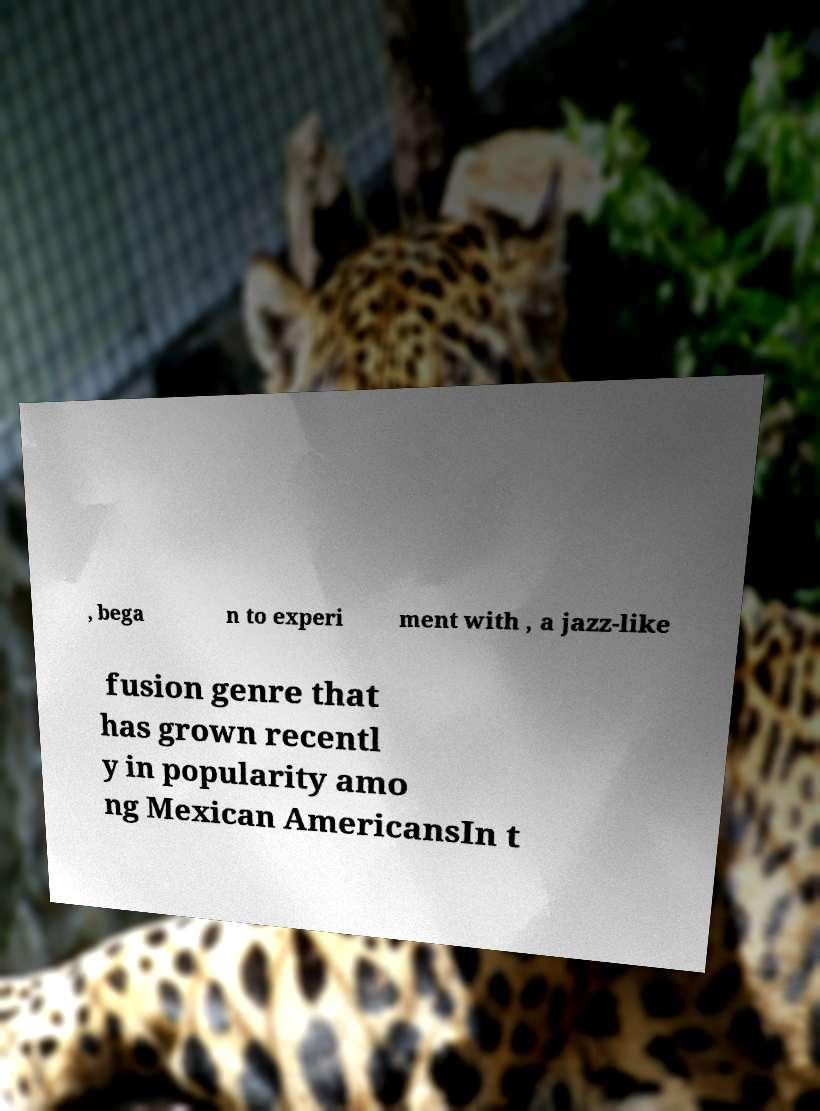Could you extract and type out the text from this image? , bega n to experi ment with , a jazz-like fusion genre that has grown recentl y in popularity amo ng Mexican AmericansIn t 